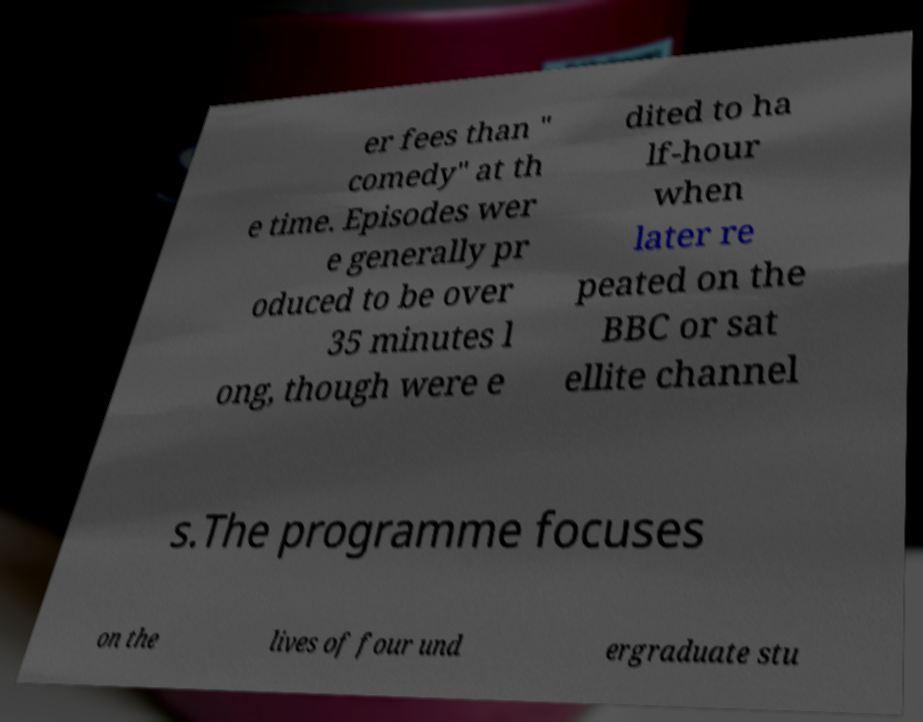Please read and relay the text visible in this image. What does it say? er fees than " comedy" at th e time. Episodes wer e generally pr oduced to be over 35 minutes l ong, though were e dited to ha lf-hour when later re peated on the BBC or sat ellite channel s.The programme focuses on the lives of four und ergraduate stu 